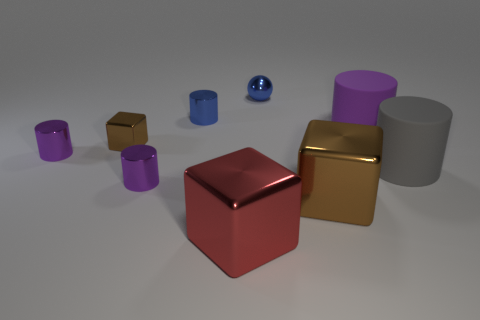The objects seem to have different textures. Could you describe them? Certainly! The purple and blue objects have a smooth and matte finish, reflecting light softly. The gold and red cubes have a metallic sheen with sharper reflections, indicating a more polished surface. The gray cylinder and the brown cube present a rougher texture with diffuse reflections that suggest a less reflective, more absorbent material. 